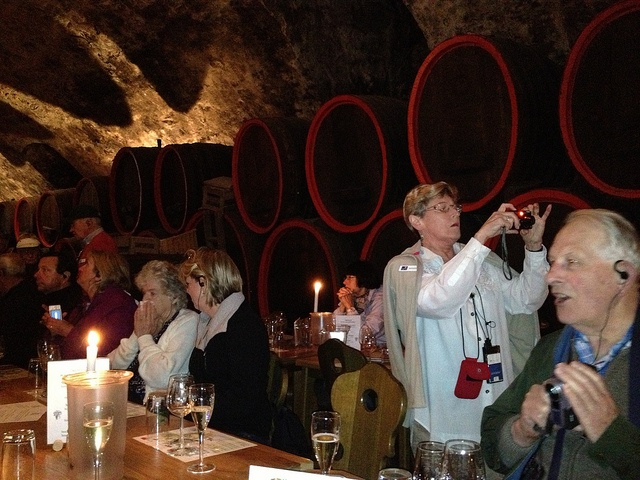Describe the objects in this image and their specific colors. I can see people in black, gray, and tan tones, dining table in black, maroon, gray, and brown tones, people in black, darkgray, lightgray, and gray tones, people in black, gray, and maroon tones, and people in black, darkgray, gray, and brown tones in this image. 